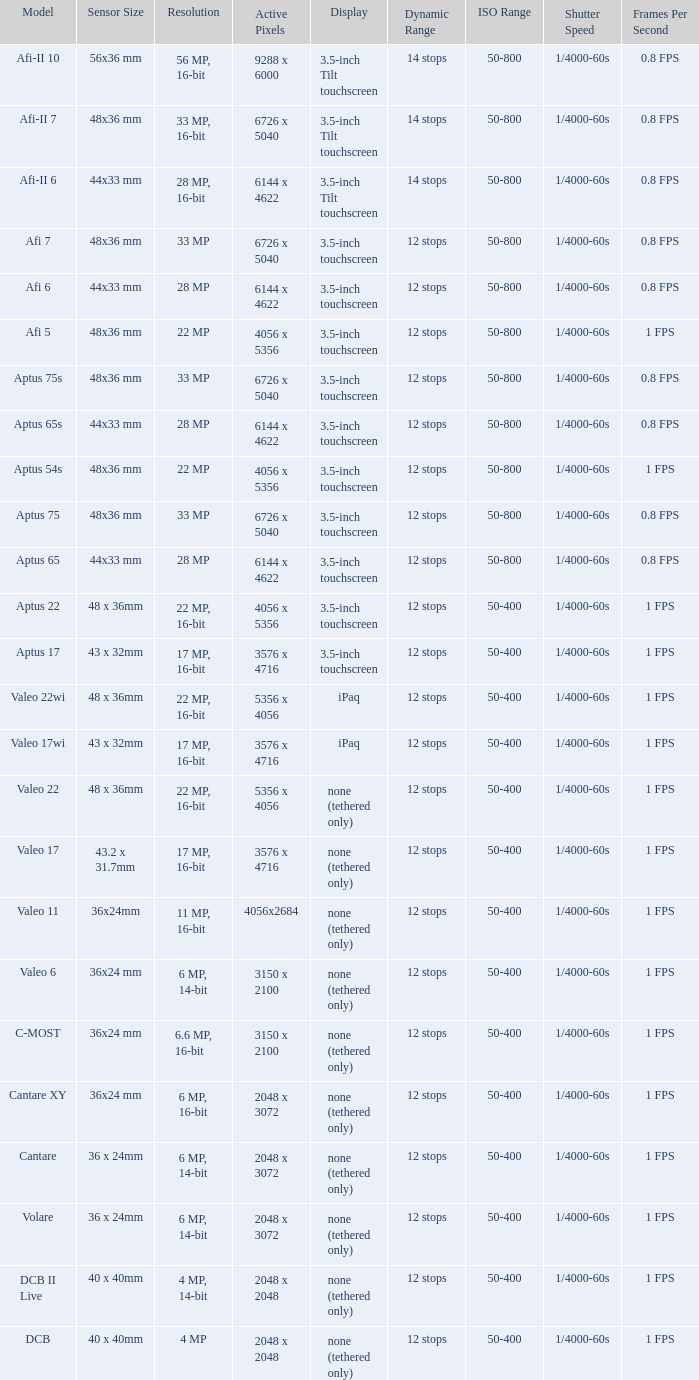What is the resolution of the camera that has 6726 x 5040 pixels and a model of afi 7? 33 MP. 